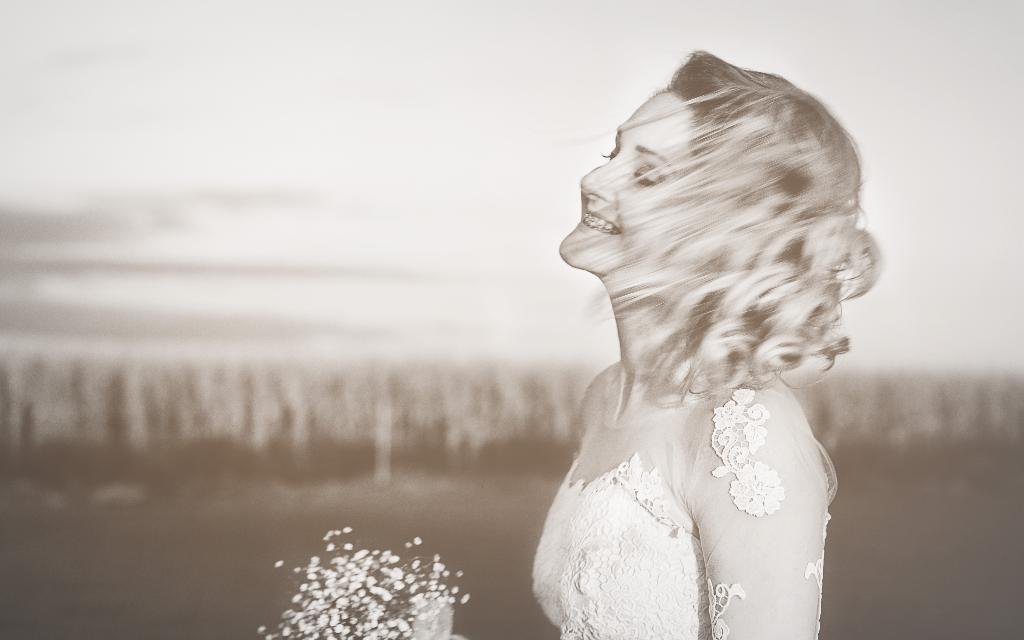What is the color scheme of the image? The image is black and white. What is the lady in the image doing? The lady is smiling in the image. What is the lady holding in the image? The lady is holding a bouquet. Where is the lady located in the image? The lady is on the right side of the image. How would you describe the background of the image? The background of the image is blurry. What type of treatment is the lady's daughter receiving in the image? There is no mention of a daughter or any treatment in the image. The image only shows a lady holding a bouquet and smiling. 